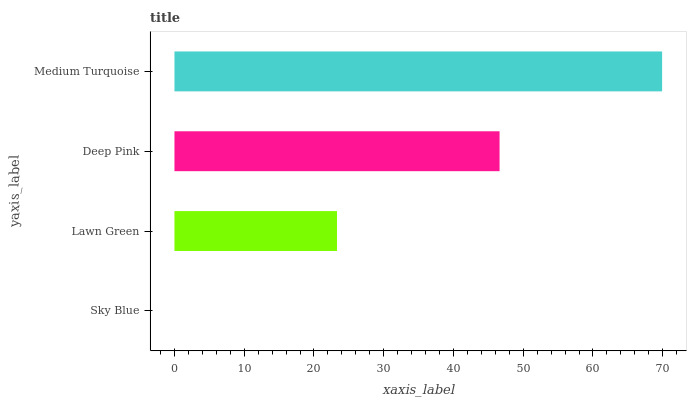Is Sky Blue the minimum?
Answer yes or no. Yes. Is Medium Turquoise the maximum?
Answer yes or no. Yes. Is Lawn Green the minimum?
Answer yes or no. No. Is Lawn Green the maximum?
Answer yes or no. No. Is Lawn Green greater than Sky Blue?
Answer yes or no. Yes. Is Sky Blue less than Lawn Green?
Answer yes or no. Yes. Is Sky Blue greater than Lawn Green?
Answer yes or no. No. Is Lawn Green less than Sky Blue?
Answer yes or no. No. Is Deep Pink the high median?
Answer yes or no. Yes. Is Lawn Green the low median?
Answer yes or no. Yes. Is Sky Blue the high median?
Answer yes or no. No. Is Sky Blue the low median?
Answer yes or no. No. 